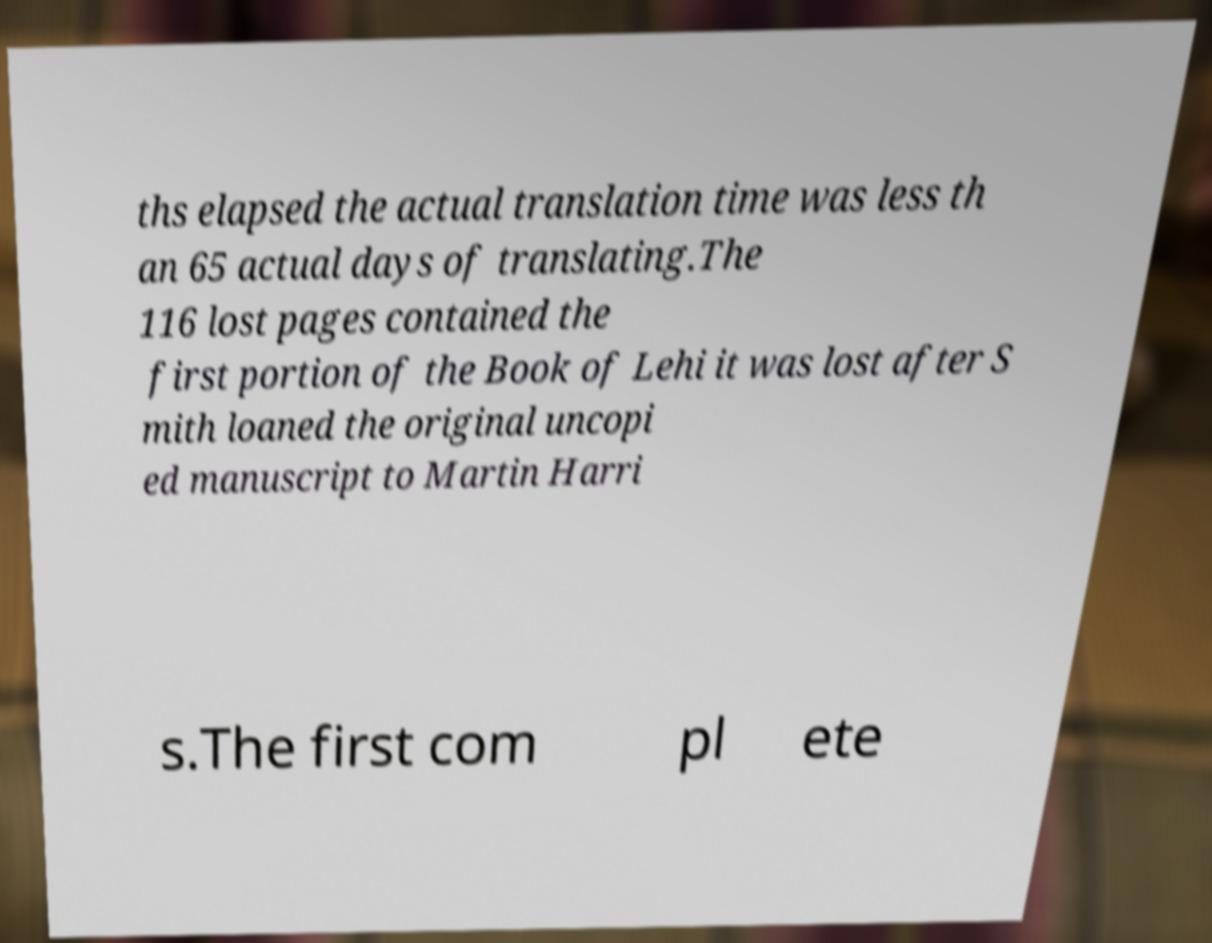Can you accurately transcribe the text from the provided image for me? ths elapsed the actual translation time was less th an 65 actual days of translating.The 116 lost pages contained the first portion of the Book of Lehi it was lost after S mith loaned the original uncopi ed manuscript to Martin Harri s.The first com pl ete 